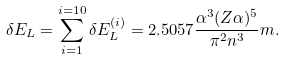Convert formula to latex. <formula><loc_0><loc_0><loc_500><loc_500>\delta E _ { L } = \sum _ { i = 1 } ^ { i = 1 0 } \delta E _ { L } ^ { ( i ) } = 2 . 5 0 5 7 \frac { \alpha ^ { 3 } ( Z \alpha ) ^ { 5 } } { \pi ^ { 2 } n ^ { 3 } } m .</formula> 